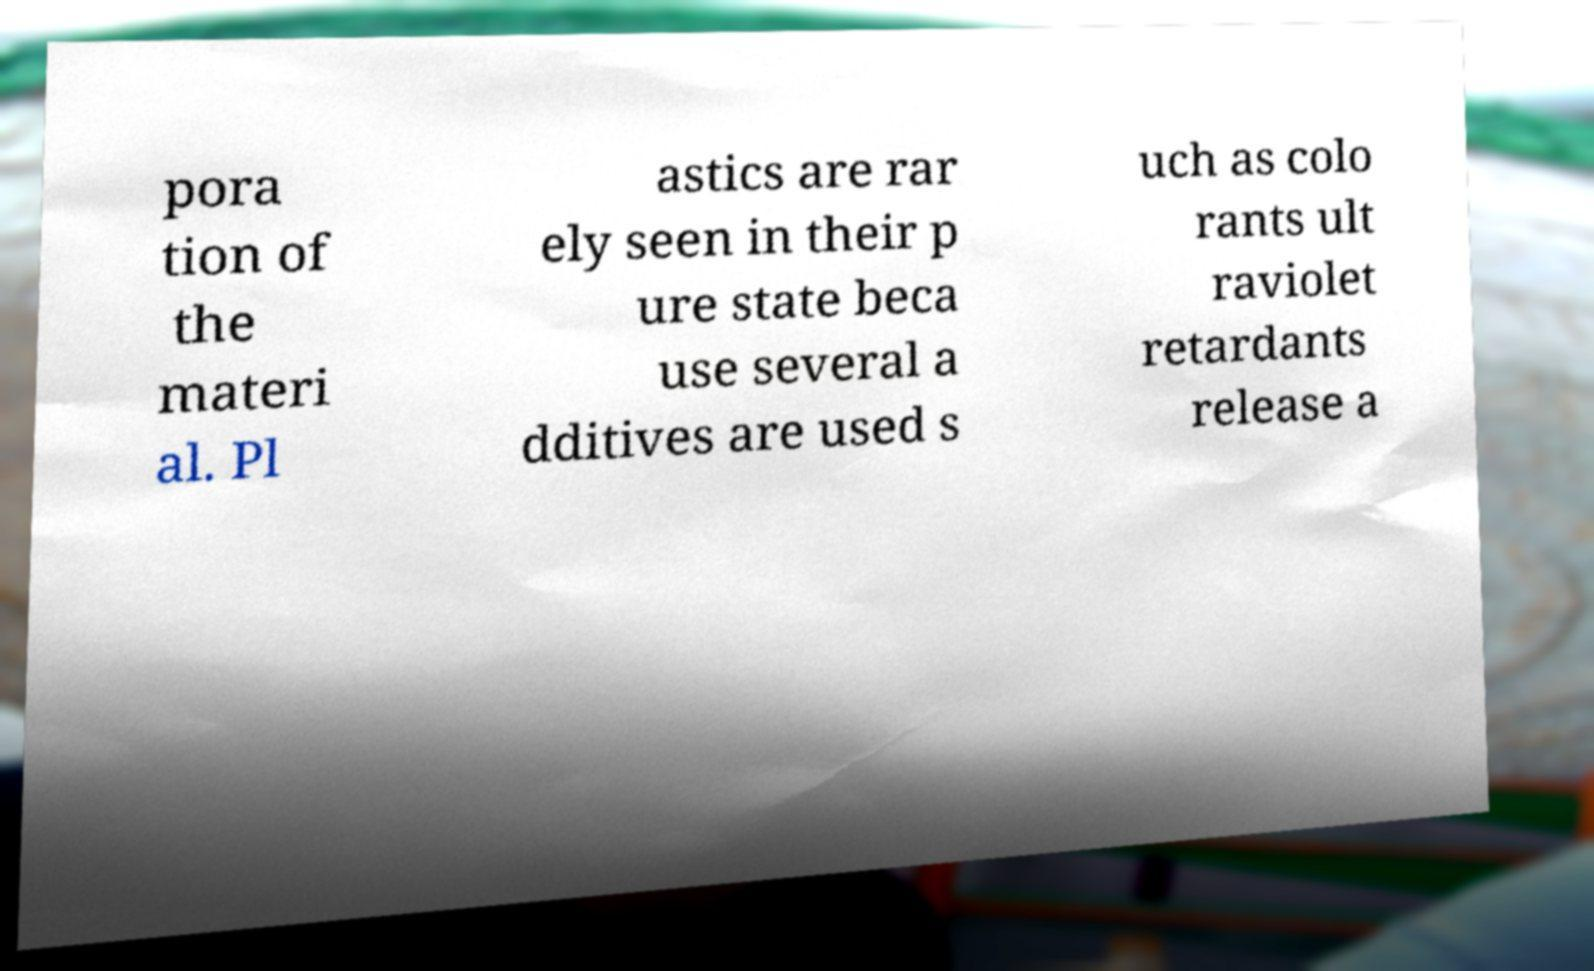Could you extract and type out the text from this image? pora tion of the materi al. Pl astics are rar ely seen in their p ure state beca use several a dditives are used s uch as colo rants ult raviolet retardants release a 